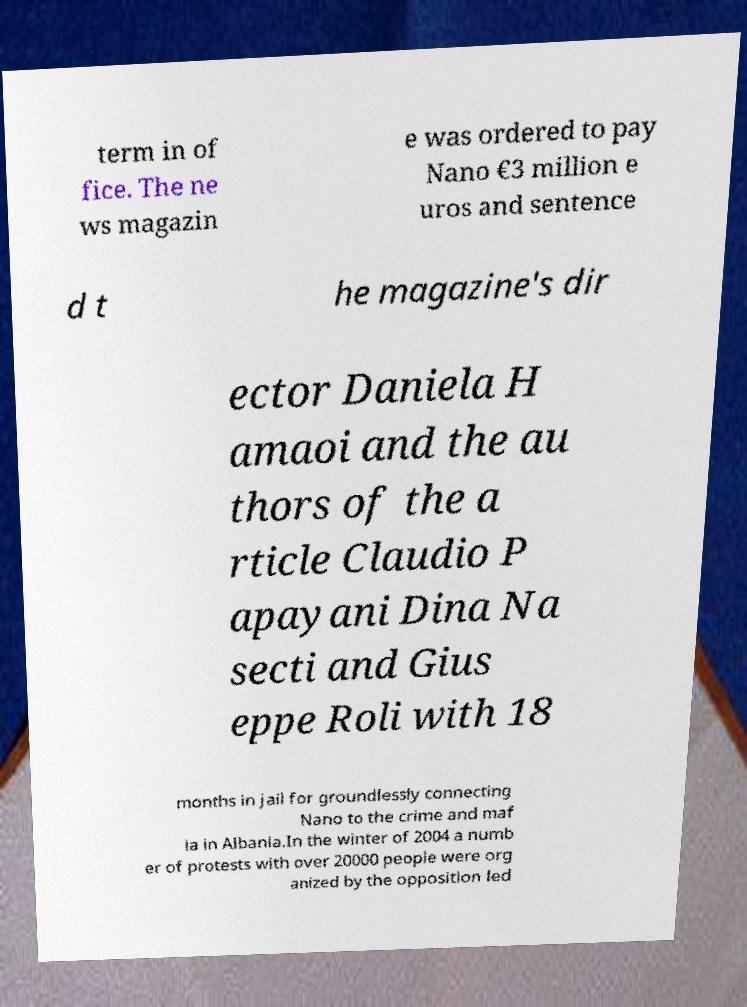I need the written content from this picture converted into text. Can you do that? term in of fice. The ne ws magazin e was ordered to pay Nano €3 million e uros and sentence d t he magazine's dir ector Daniela H amaoi and the au thors of the a rticle Claudio P apayani Dina Na secti and Gius eppe Roli with 18 months in jail for groundlessly connecting Nano to the crime and maf ia in Albania.In the winter of 2004 a numb er of protests with over 20000 people were org anized by the opposition led 